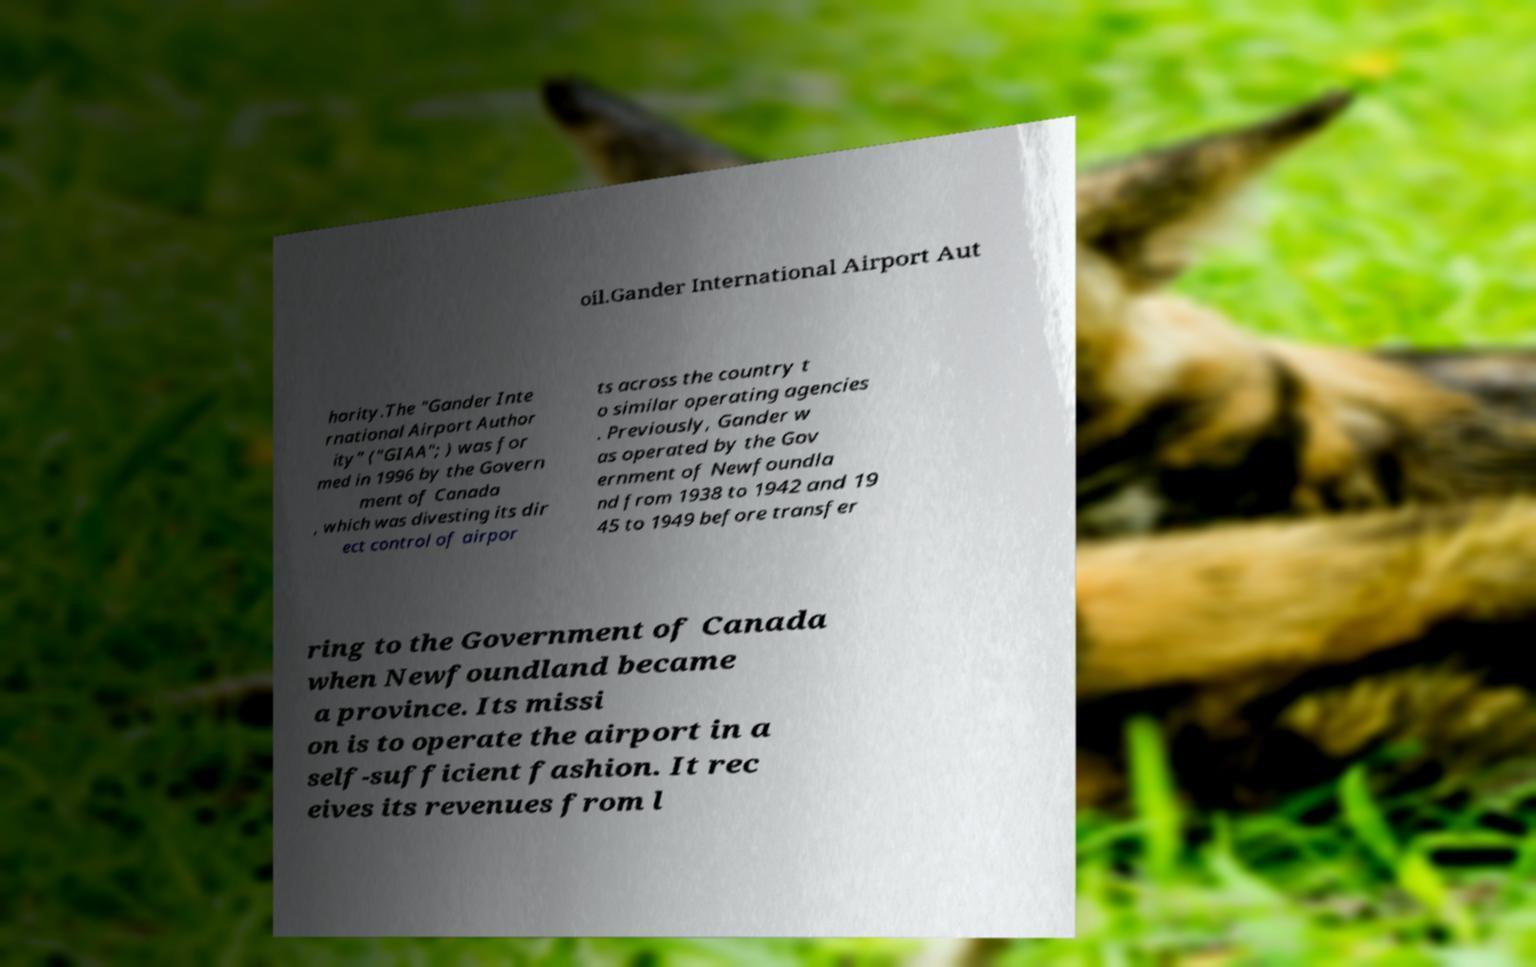Can you accurately transcribe the text from the provided image for me? oil.Gander International Airport Aut hority.The "Gander Inte rnational Airport Author ity" ("GIAA"; ) was for med in 1996 by the Govern ment of Canada , which was divesting its dir ect control of airpor ts across the country t o similar operating agencies . Previously, Gander w as operated by the Gov ernment of Newfoundla nd from 1938 to 1942 and 19 45 to 1949 before transfer ring to the Government of Canada when Newfoundland became a province. Its missi on is to operate the airport in a self-sufficient fashion. It rec eives its revenues from l 